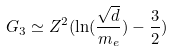Convert formula to latex. <formula><loc_0><loc_0><loc_500><loc_500>G _ { 3 } \simeq Z ^ { 2 } ( \ln ( \frac { \sqrt { d } } { m _ { e } } ) - \frac { 3 } { 2 } )</formula> 